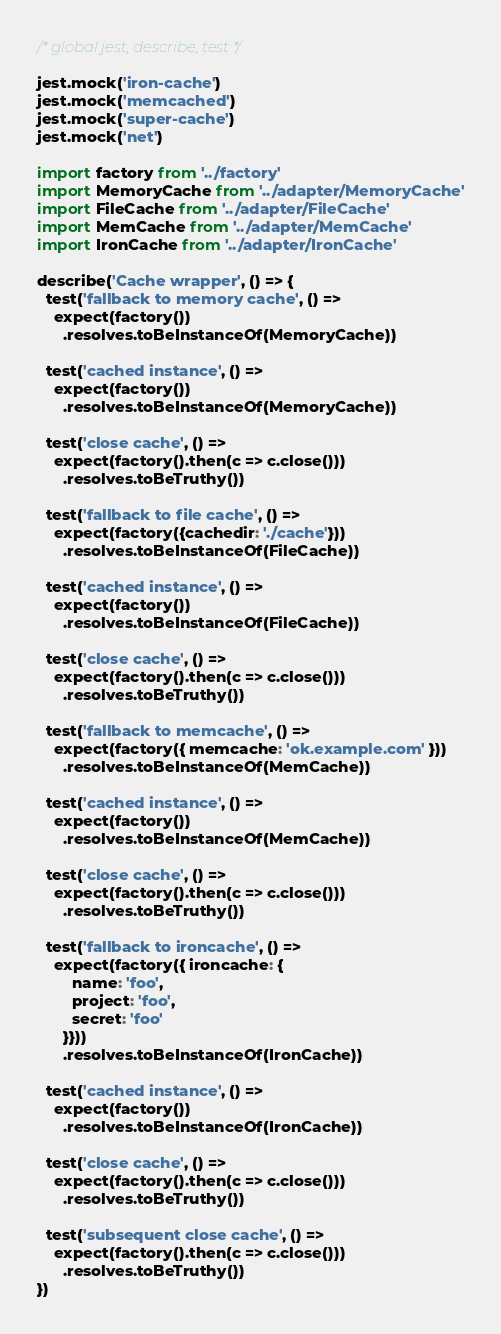Convert code to text. <code><loc_0><loc_0><loc_500><loc_500><_TypeScript_>/* global jest, describe, test */

jest.mock('iron-cache')
jest.mock('memcached')
jest.mock('super-cache')
jest.mock('net')

import factory from '../factory'
import MemoryCache from '../adapter/MemoryCache'
import FileCache from '../adapter/FileCache'
import MemCache from '../adapter/MemCache'
import IronCache from '../adapter/IronCache'

describe('Cache wrapper', () => {
  test('fallback to memory cache', () =>
    expect(factory())
      .resolves.toBeInstanceOf(MemoryCache))

  test('cached instance', () =>
    expect(factory())
      .resolves.toBeInstanceOf(MemoryCache))

  test('close cache', () =>
    expect(factory().then(c => c.close()))
      .resolves.toBeTruthy())

  test('fallback to file cache', () =>
    expect(factory({cachedir: './cache'}))
      .resolves.toBeInstanceOf(FileCache))

  test('cached instance', () =>
    expect(factory())
      .resolves.toBeInstanceOf(FileCache))

  test('close cache', () =>
    expect(factory().then(c => c.close()))
      .resolves.toBeTruthy())

  test('fallback to memcache', () =>
    expect(factory({ memcache: 'ok.example.com' }))
      .resolves.toBeInstanceOf(MemCache))

  test('cached instance', () =>
    expect(factory())
      .resolves.toBeInstanceOf(MemCache))

  test('close cache', () =>
    expect(factory().then(c => c.close()))
      .resolves.toBeTruthy())

  test('fallback to ironcache', () =>
    expect(factory({ ironcache: {
        name: 'foo',
        project: 'foo',
        secret: 'foo'
      }}))
      .resolves.toBeInstanceOf(IronCache))

  test('cached instance', () =>
    expect(factory())
      .resolves.toBeInstanceOf(IronCache))

  test('close cache', () =>
    expect(factory().then(c => c.close()))
      .resolves.toBeTruthy())

  test('subsequent close cache', () =>
    expect(factory().then(c => c.close()))
      .resolves.toBeTruthy())
})
</code> 